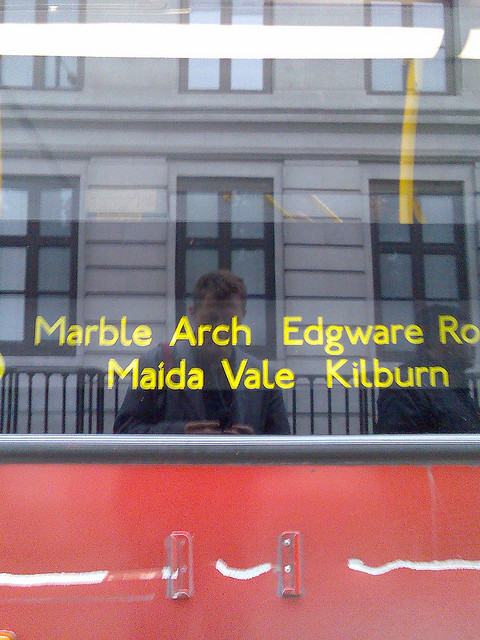Identify the text contained in this image. Marble Maida Arch Vale edgware Kilburn RO 